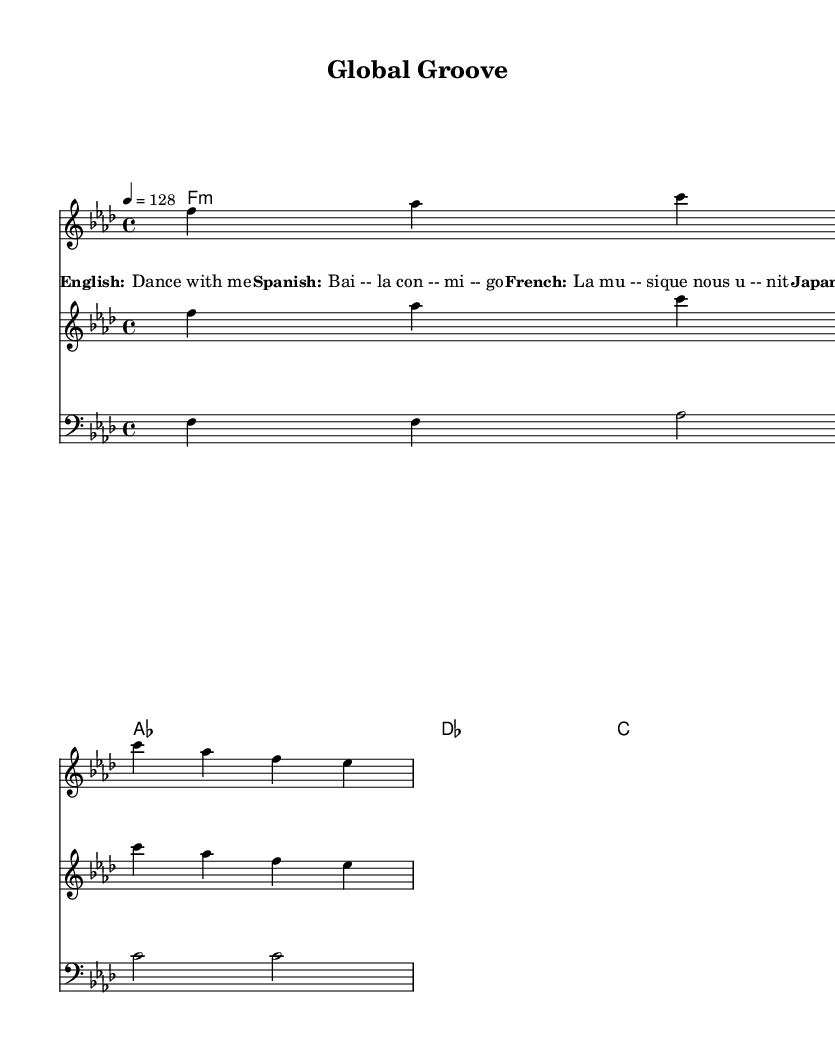What is the key signature of this music? The key signature is indicated by the symbols at the beginning of the staff. In this case, the music is in F minor, which has four flats.
Answer: F minor What is the time signature of this piece? The time signature is shown at the beginning of the score. Here, it is 4/4, meaning there are four beats in each measure, and the quarter note receives one beat.
Answer: 4/4 What is the tempo marking for this track? The tempo marking is placed above the staff as a number. In this score, it is marked as 128 beats per minute, indicating the speed of the music.
Answer: 128 How many distinct vocal languages are used in the lyrics? To identify the number of distinct vocal languages, we look at the lyric samples provided. The lyrics include English, Spanish, French, and Japanese, which totals four languages.
Answer: Four How many measures are in the melody? We can count the number of measures in the melody section, each separated by a vertical line. The melody has a total of two measures as indicated by the groupings of the notes.
Answer: Two What type of chord is found in the first measure? The first measure contains a chord symbol above the corresponding staff. The chord indicated is F minor, which is a minor chord consisting of the root note F, a minor third (Ab), and a perfect fifth (C).
Answer: F minor 